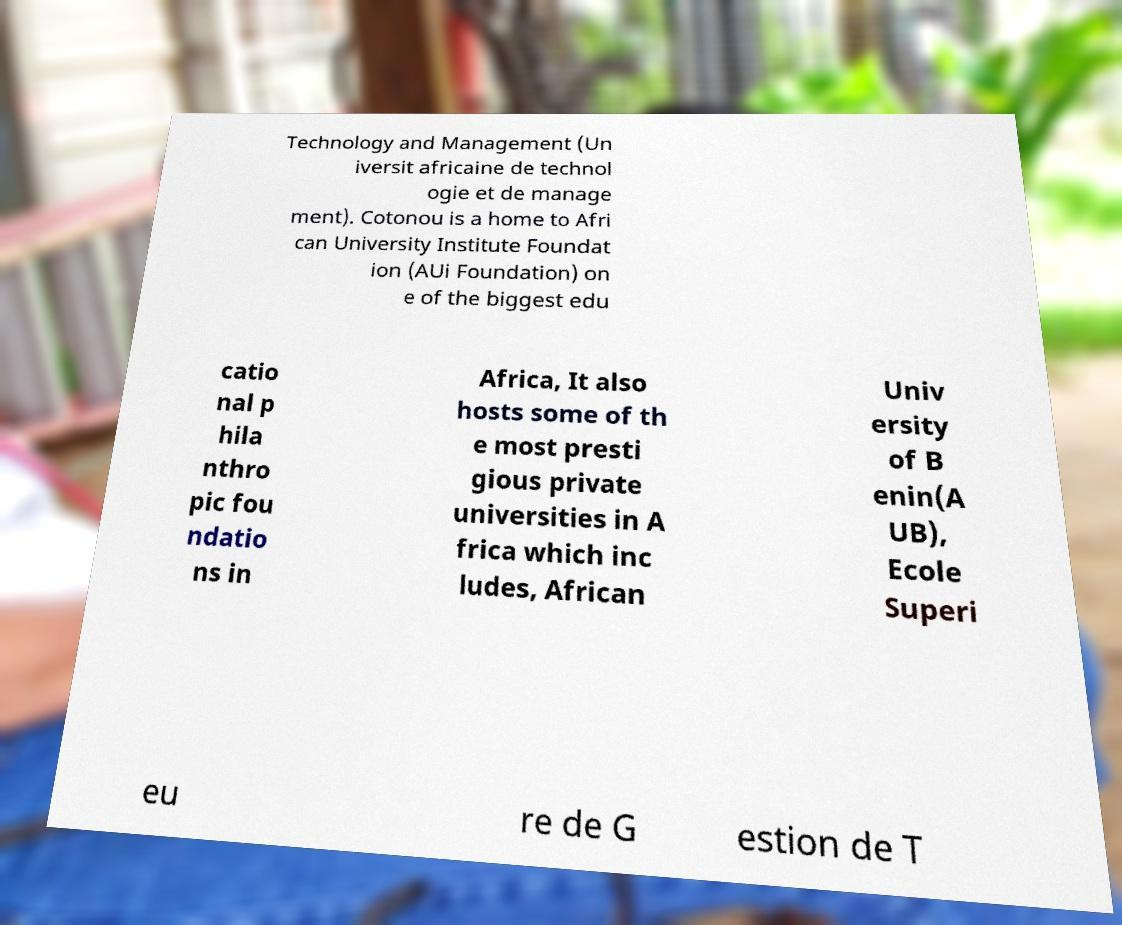Could you assist in decoding the text presented in this image and type it out clearly? Technology and Management (Un iversit africaine de technol ogie et de manage ment). Cotonou is a home to Afri can University Institute Foundat ion (AUi Foundation) on e of the biggest edu catio nal p hila nthro pic fou ndatio ns in Africa, It also hosts some of th e most presti gious private universities in A frica which inc ludes, African Univ ersity of B enin(A UB), Ecole Superi eu re de G estion de T 